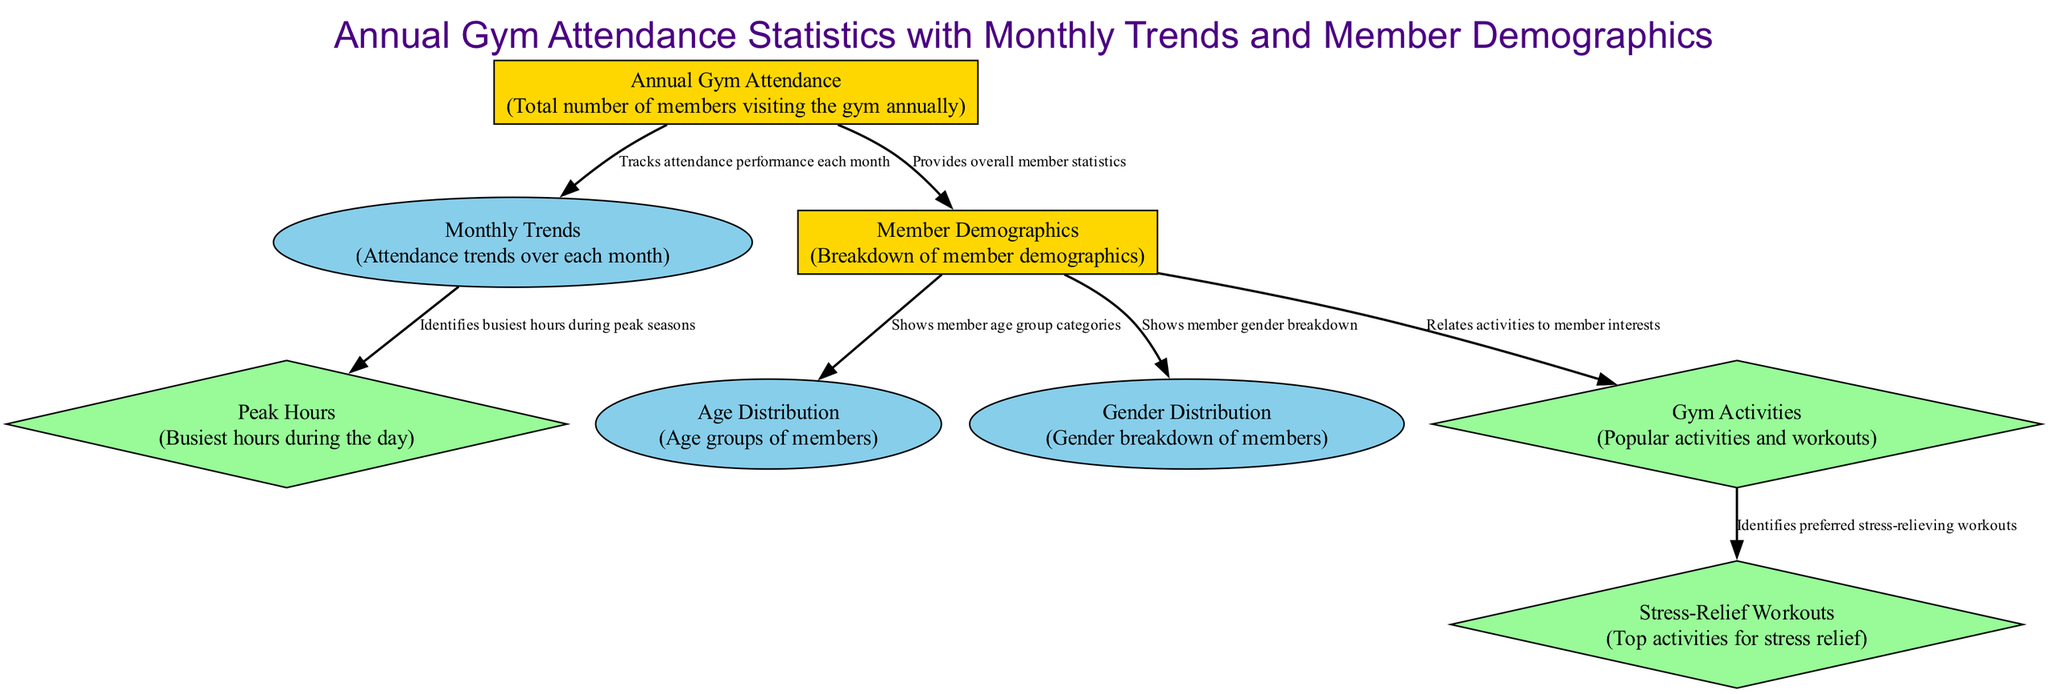What is the main topic of the diagram? The main topic is clearly stated in the title of the diagram, which includes "Annual Gym Attendance Statistics with Monthly Trends and Member Demographics." Thus, the main focus is on gym attendance data.
Answer: Annual Gym Attendance Statistics with Monthly Trends and Member Demographics How many main nodes are present in the diagram? The diagram identifies two main nodes: "Annual Gym Attendance" and "Member Demographics." Therefore, by counting them, we find there are two main nodes.
Answer: 2 What do the "Monthly Trends" connect to in the diagram? "Monthly Trends" is connected to "Peak Hours," showing that it tracks attendance performance and identifies when the busiest hours occur.
Answer: Peak Hours Which demographic group is broken down into age categories? The "Age Distribution" node is connected to the "Member Demographics" node, indicating that it shows categories based on the ages of gym members.
Answer: Age Distribution What activities are focused on for stress relief? The "Stress-Relief Workouts" node is linked to "Gym Activities," which highlights the popular workouts and activities specifically known for relieving stress.
Answer: Stress-Relief Workouts How many data nodes are present in the diagram? The diagram presents three data nodes: "Peak Hours," "Gym Activities," and "Stress-Relief Workouts," which can be identified by their shapes and descriptions.
Answer: 3 Which main node is related to the total number of members visiting annually? The "Annual Gym Attendance" node represents the total count of members attending the gym over the year, highlighting overall attendance levels.
Answer: Annual Gym Attendance Which node describes the busiest hours during peak seasons? The "Peak Hours" node is associated with the "Monthly Trends," pointing out when the most members visit the gym during certain times of the year.
Answer: Peak Hours What relationship exists between "Member Demographics" and "Gender Distribution"? "Member Demographics" connects to "Gender Distribution," demonstrating how members are categorized based on their gender.
Answer: Gender Distribution 